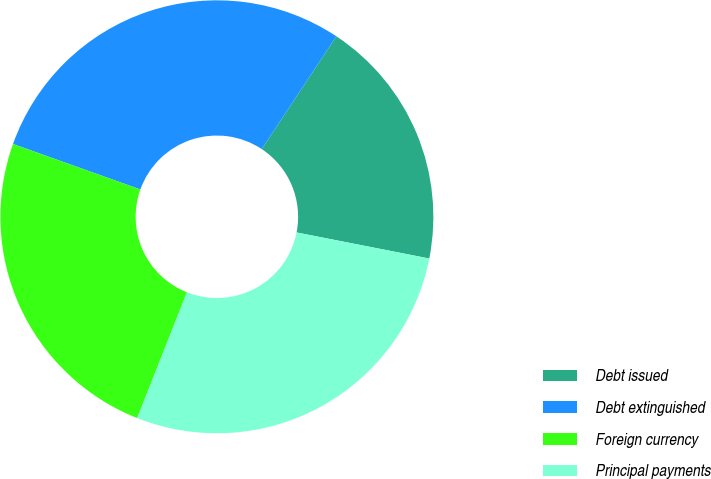Convert chart to OTSL. <chart><loc_0><loc_0><loc_500><loc_500><pie_chart><fcel>Debt issued<fcel>Debt extinguished<fcel>Foreign currency<fcel>Principal payments<nl><fcel>18.78%<fcel>28.85%<fcel>24.46%<fcel>27.91%<nl></chart> 